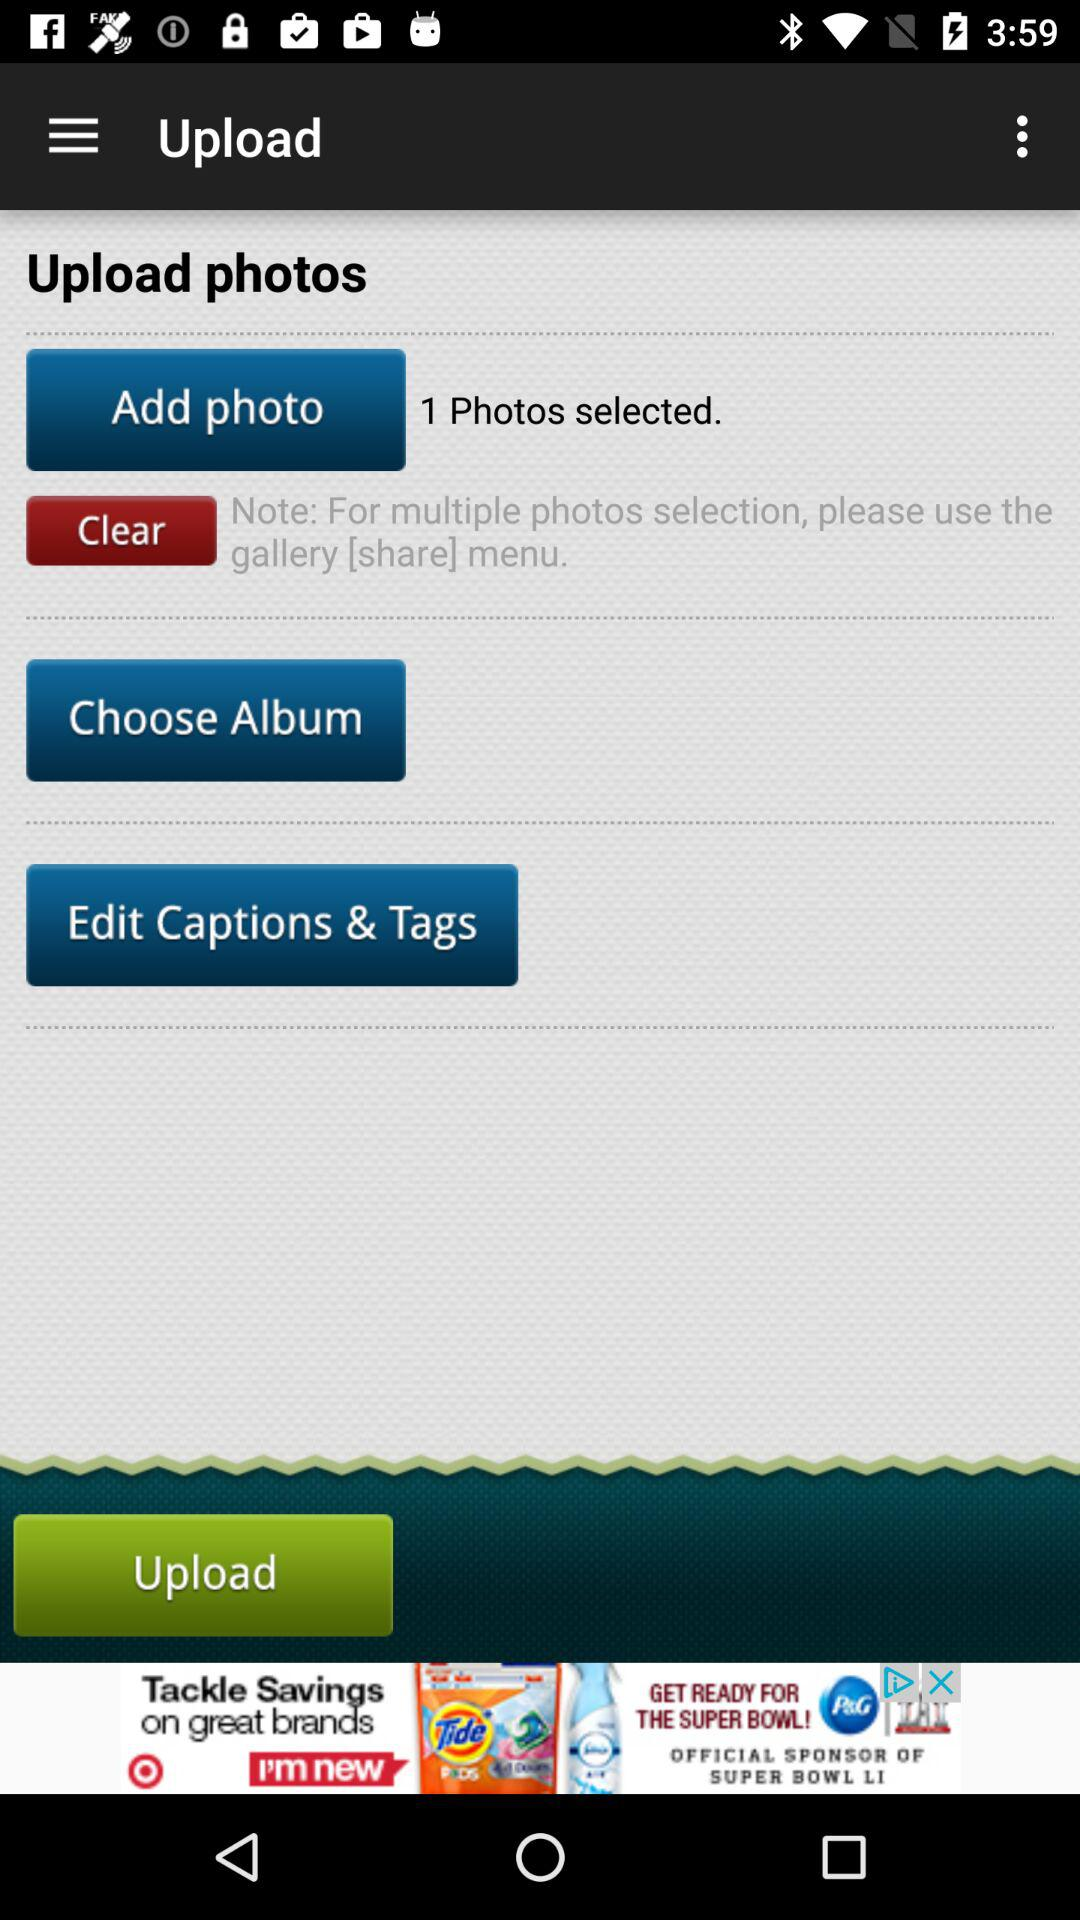How many photos have been selected?
Answer the question using a single word or phrase. 1 